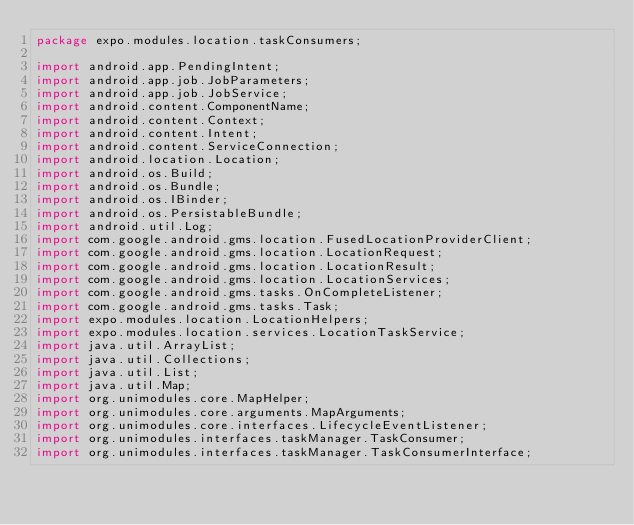Convert code to text. <code><loc_0><loc_0><loc_500><loc_500><_Java_>package expo.modules.location.taskConsumers;

import android.app.PendingIntent;
import android.app.job.JobParameters;
import android.app.job.JobService;
import android.content.ComponentName;
import android.content.Context;
import android.content.Intent;
import android.content.ServiceConnection;
import android.location.Location;
import android.os.Build;
import android.os.Bundle;
import android.os.IBinder;
import android.os.PersistableBundle;
import android.util.Log;
import com.google.android.gms.location.FusedLocationProviderClient;
import com.google.android.gms.location.LocationRequest;
import com.google.android.gms.location.LocationResult;
import com.google.android.gms.location.LocationServices;
import com.google.android.gms.tasks.OnCompleteListener;
import com.google.android.gms.tasks.Task;
import expo.modules.location.LocationHelpers;
import expo.modules.location.services.LocationTaskService;
import java.util.ArrayList;
import java.util.Collections;
import java.util.List;
import java.util.Map;
import org.unimodules.core.MapHelper;
import org.unimodules.core.arguments.MapArguments;
import org.unimodules.core.interfaces.LifecycleEventListener;
import org.unimodules.interfaces.taskManager.TaskConsumer;
import org.unimodules.interfaces.taskManager.TaskConsumerInterface;</code> 